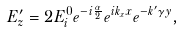Convert formula to latex. <formula><loc_0><loc_0><loc_500><loc_500>E _ { z } ^ { \prime } = 2 E _ { i } ^ { 0 } e ^ { - i \frac { \alpha } { 2 } } e ^ { i k _ { x } x } e ^ { - k ^ { \prime } \gamma y } ,</formula> 